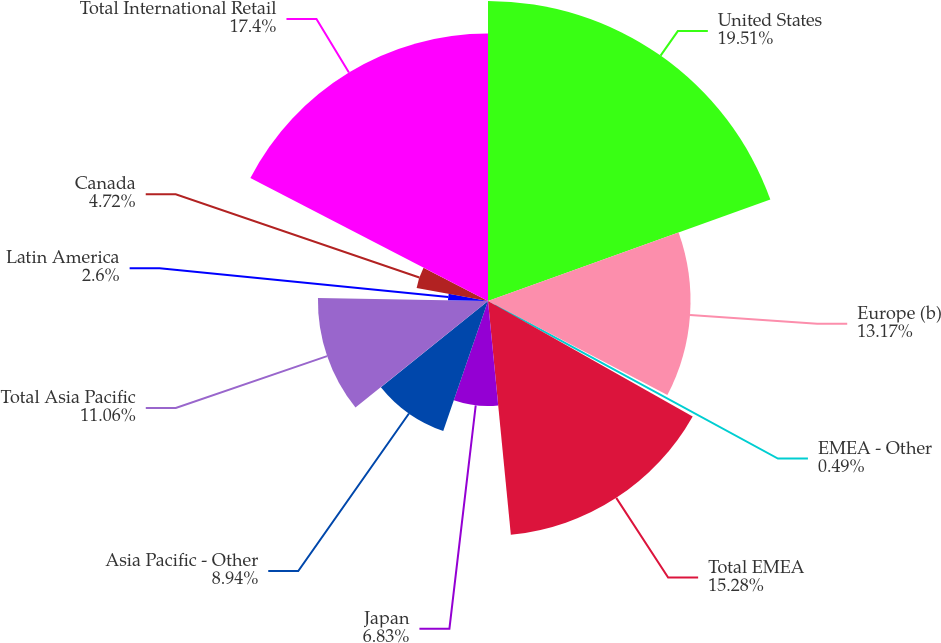<chart> <loc_0><loc_0><loc_500><loc_500><pie_chart><fcel>United States<fcel>Europe (b)<fcel>EMEA - Other<fcel>Total EMEA<fcel>Japan<fcel>Asia Pacific - Other<fcel>Total Asia Pacific<fcel>Latin America<fcel>Canada<fcel>Total International Retail<nl><fcel>19.51%<fcel>13.17%<fcel>0.49%<fcel>15.28%<fcel>6.83%<fcel>8.94%<fcel>11.06%<fcel>2.6%<fcel>4.72%<fcel>17.4%<nl></chart> 